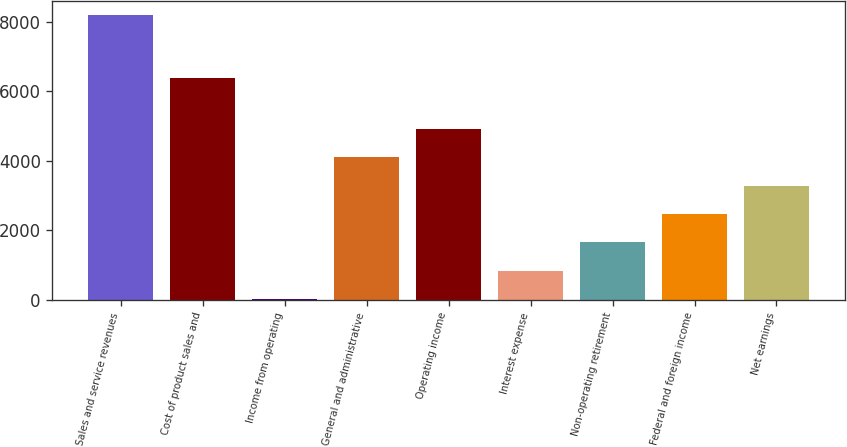Convert chart. <chart><loc_0><loc_0><loc_500><loc_500><bar_chart><fcel>Sales and service revenues<fcel>Cost of product sales and<fcel>Income from operating<fcel>General and administrative<fcel>Operating income<fcel>Interest expense<fcel>Non-operating retirement<fcel>Federal and foreign income<fcel>Net earnings<nl><fcel>8176<fcel>6385<fcel>17<fcel>4096.5<fcel>4912.4<fcel>832.9<fcel>1648.8<fcel>2464.7<fcel>3280.6<nl></chart> 